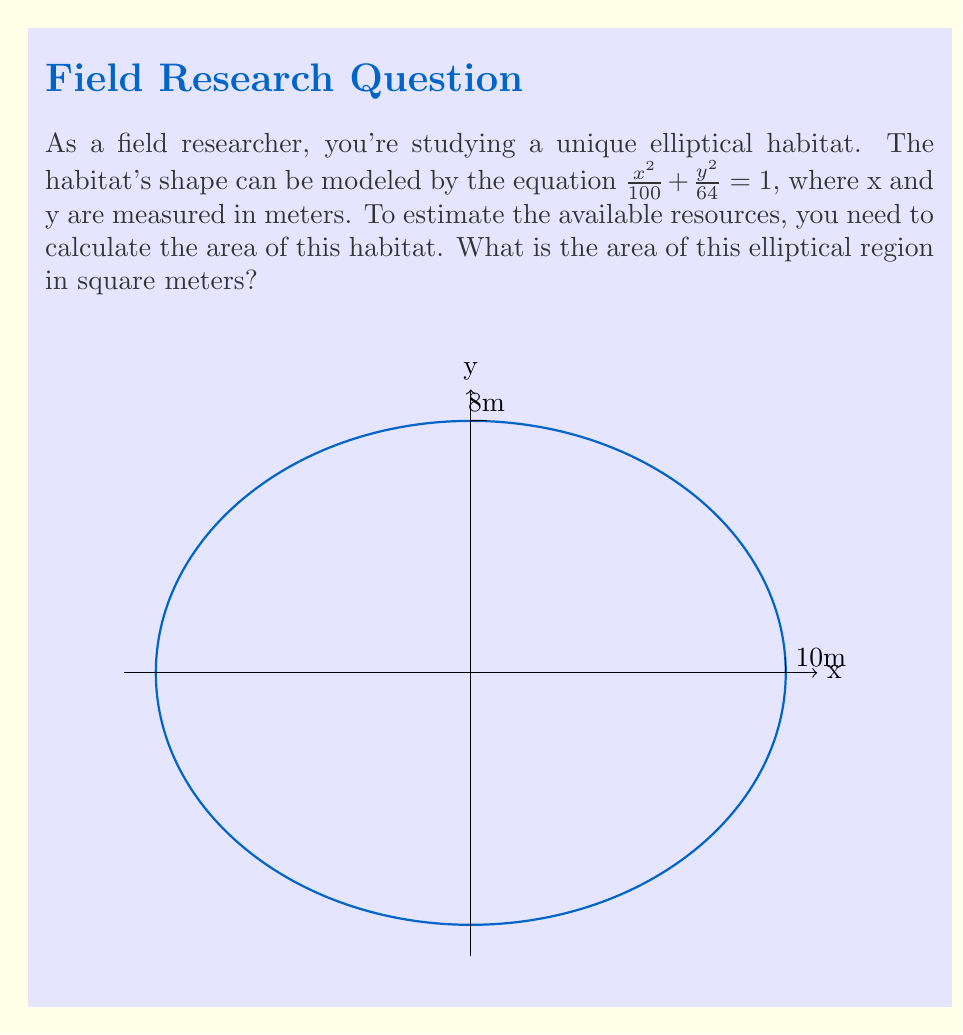Give your solution to this math problem. To solve this problem, we'll follow these steps:

1) The general equation of an ellipse is $\frac{x^2}{a^2} + \frac{y^2}{b^2} = 1$, where a and b are the lengths of the semi-major and semi-minor axes.

2) From our equation $\frac{x^2}{100} + \frac{y^2}{64} = 1$, we can identify:
   $a^2 = 100$, so $a = 10$ meters
   $b^2 = 64$, so $b = 8$ meters

3) The formula for the area of an ellipse is $A = \pi ab$

4) Substituting our values:
   $A = \pi(10)(8)$
   $A = 80\pi$

5) If we want to express this in square meters with two decimal places:
   $A \approx 251.33$ square meters

Therefore, the area of the elliptical habitat is $80\pi$ or approximately 251.33 square meters.
Answer: $80\pi$ square meters 